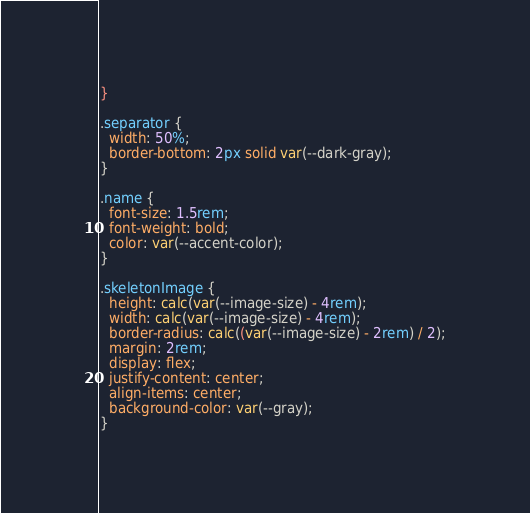<code> <loc_0><loc_0><loc_500><loc_500><_CSS_>}

.separator {
  width: 50%;
  border-bottom: 2px solid var(--dark-gray);
}

.name {
  font-size: 1.5rem;
  font-weight: bold;
  color: var(--accent-color);
}

.skeletonImage {
  height: calc(var(--image-size) - 4rem);
  width: calc(var(--image-size) - 4rem);
  border-radius: calc((var(--image-size) - 2rem) / 2);
  margin: 2rem;
  display: flex;
  justify-content: center;
  align-items: center;
  background-color: var(--gray);
}
</code> 